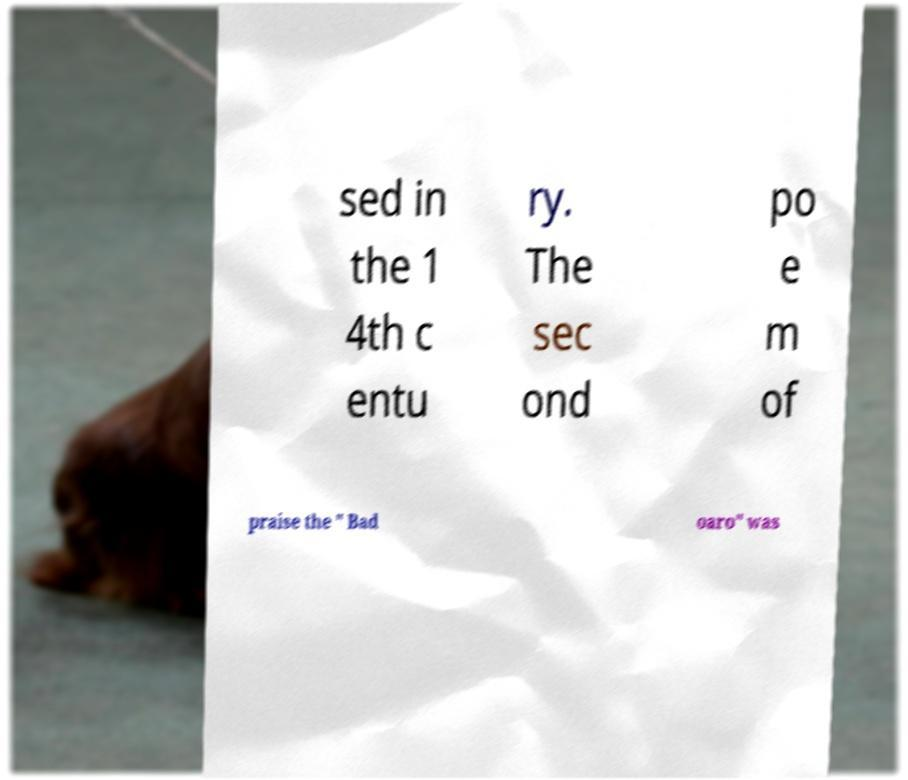Could you assist in decoding the text presented in this image and type it out clearly? sed in the 1 4th c entu ry. The sec ond po e m of praise the " Bad oaro" was 